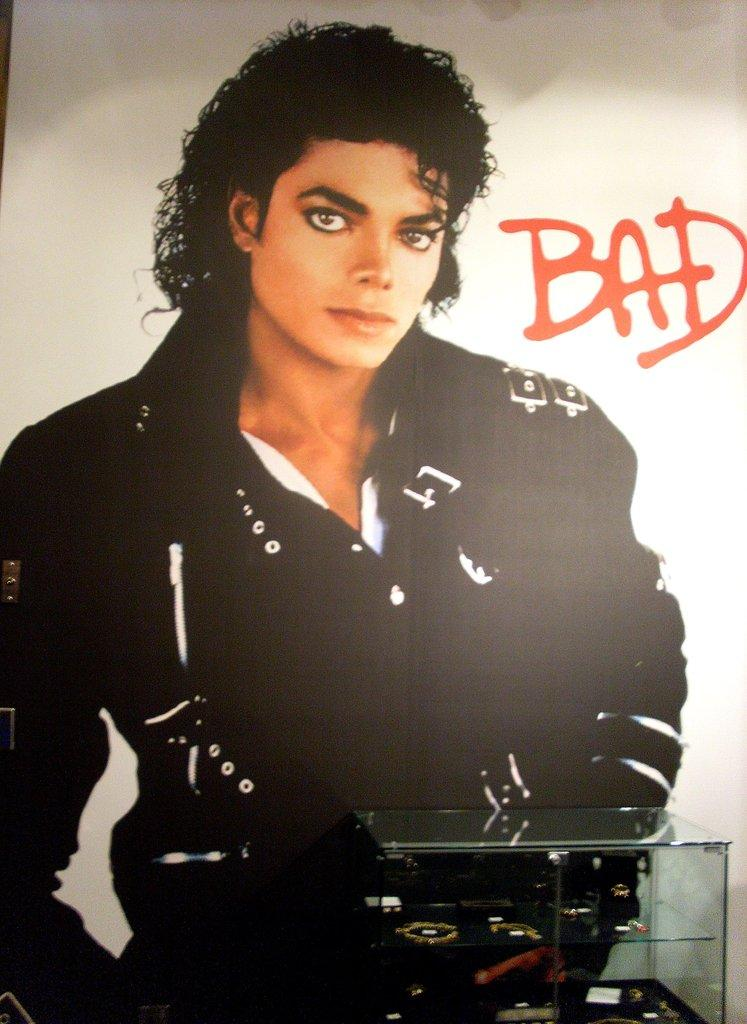What is contained within the glass box in the image? There are objects in a glass box in the image. What can be seen in the background of the image? There is a poster of Michael Jackson in the background of the image. How many cards are being played on the land in the image? There are no cards or land present in the image. What type of rail is visible in the image? There is no rail present in the image. 